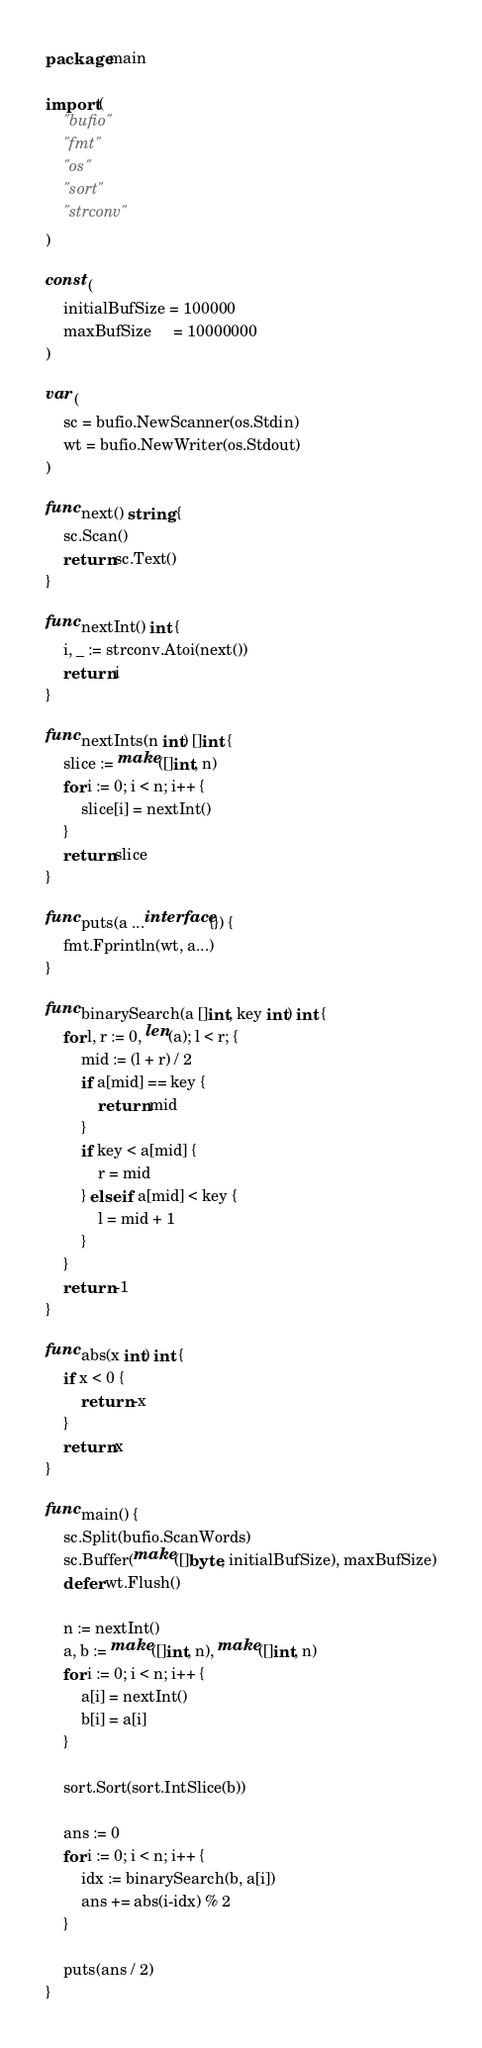Convert code to text. <code><loc_0><loc_0><loc_500><loc_500><_Go_>package main

import (
	"bufio"
	"fmt"
	"os"
	"sort"
	"strconv"
)

const (
	initialBufSize = 100000
	maxBufSize     = 10000000
)

var (
	sc = bufio.NewScanner(os.Stdin)
	wt = bufio.NewWriter(os.Stdout)
)

func next() string {
	sc.Scan()
	return sc.Text()
}

func nextInt() int {
	i, _ := strconv.Atoi(next())
	return i
}

func nextInts(n int) []int {
	slice := make([]int, n)
	for i := 0; i < n; i++ {
		slice[i] = nextInt()
	}
	return slice
}

func puts(a ...interface{}) {
	fmt.Fprintln(wt, a...)
}

func binarySearch(a []int, key int) int {
	for l, r := 0, len(a); l < r; {
		mid := (l + r) / 2
		if a[mid] == key {
			return mid
		}
		if key < a[mid] {
			r = mid
		} else if a[mid] < key {
			l = mid + 1
		}
	}
	return -1
}

func abs(x int) int {
	if x < 0 {
		return -x
	}
	return x
}

func main() {
	sc.Split(bufio.ScanWords)
	sc.Buffer(make([]byte, initialBufSize), maxBufSize)
	defer wt.Flush()

	n := nextInt()
	a, b := make([]int, n), make([]int, n)
	for i := 0; i < n; i++ {
		a[i] = nextInt()
		b[i] = a[i]
	}

	sort.Sort(sort.IntSlice(b))

	ans := 0
	for i := 0; i < n; i++ {
		idx := binarySearch(b, a[i])
		ans += abs(i-idx) % 2
	}

	puts(ans / 2)
}
</code> 